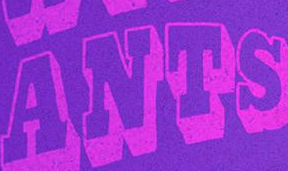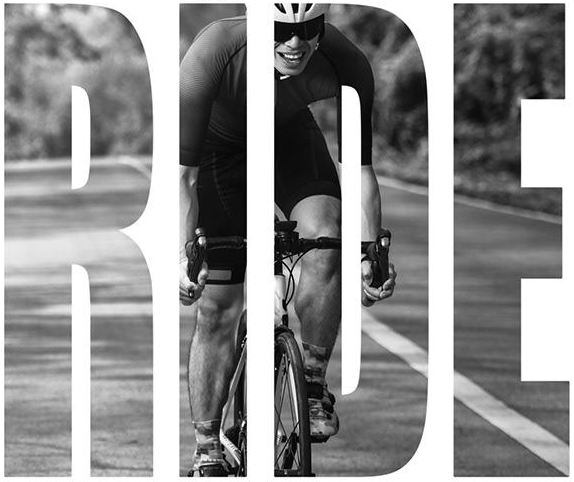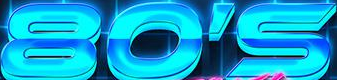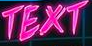What words are shown in these images in order, separated by a semicolon? ANTS; RIDE; 80'S; TEXT 